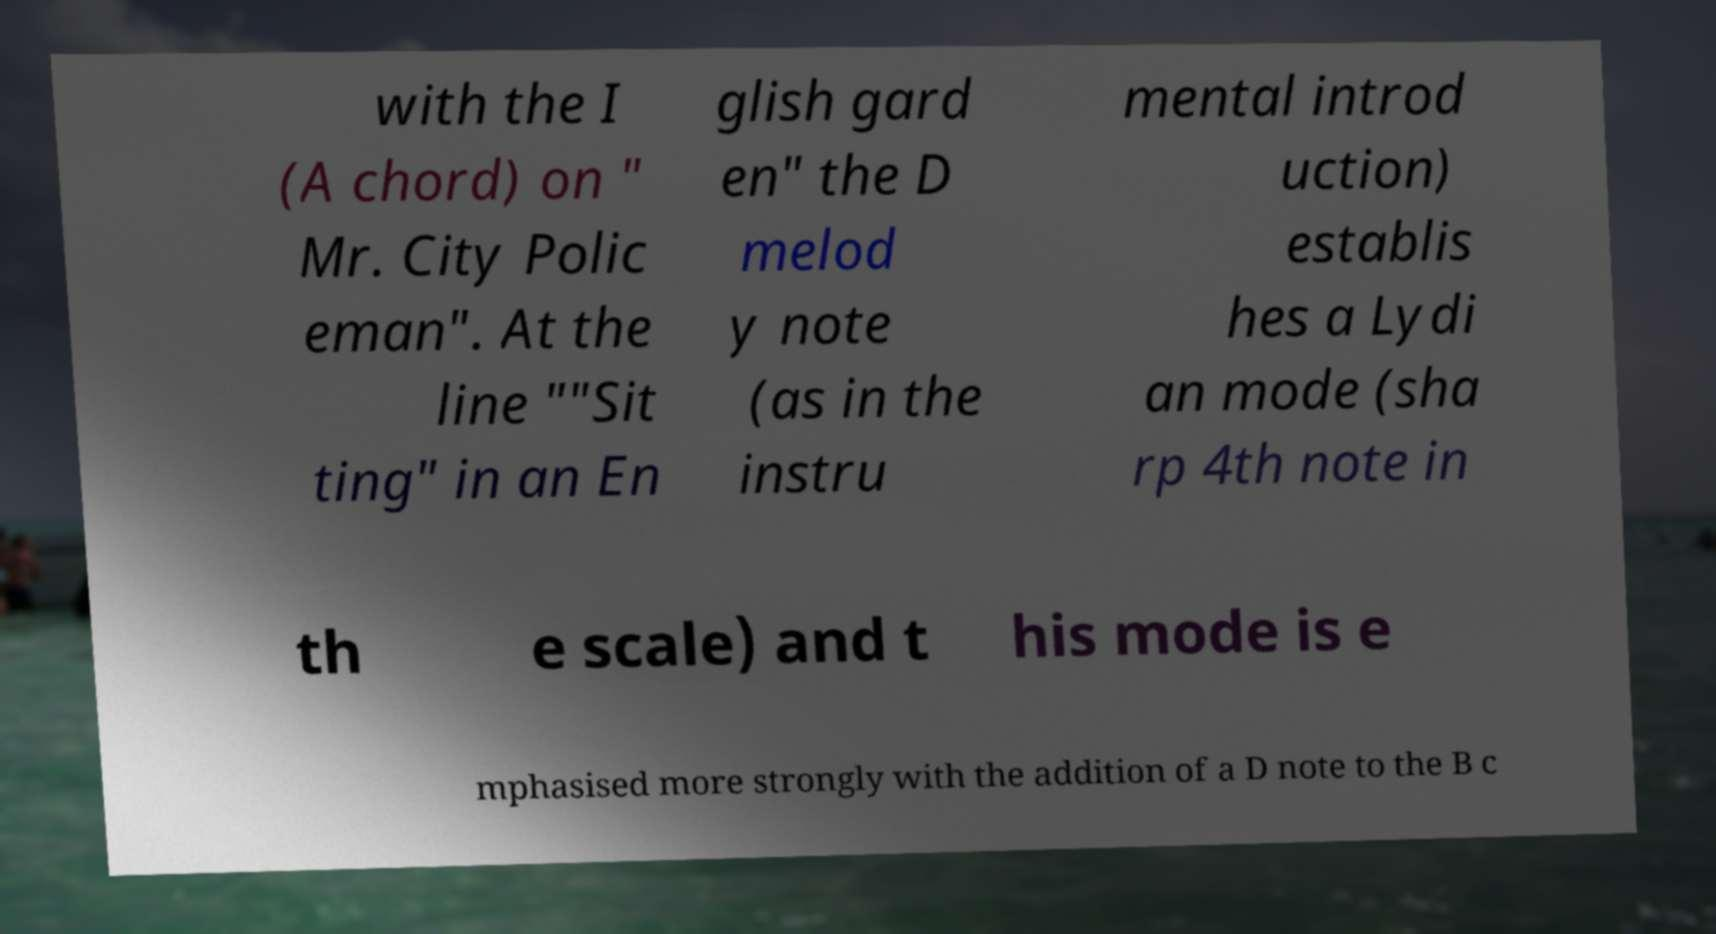Could you extract and type out the text from this image? with the I (A chord) on " Mr. City Polic eman". At the line ""Sit ting" in an En glish gard en" the D melod y note (as in the instru mental introd uction) establis hes a Lydi an mode (sha rp 4th note in th e scale) and t his mode is e mphasised more strongly with the addition of a D note to the B c 